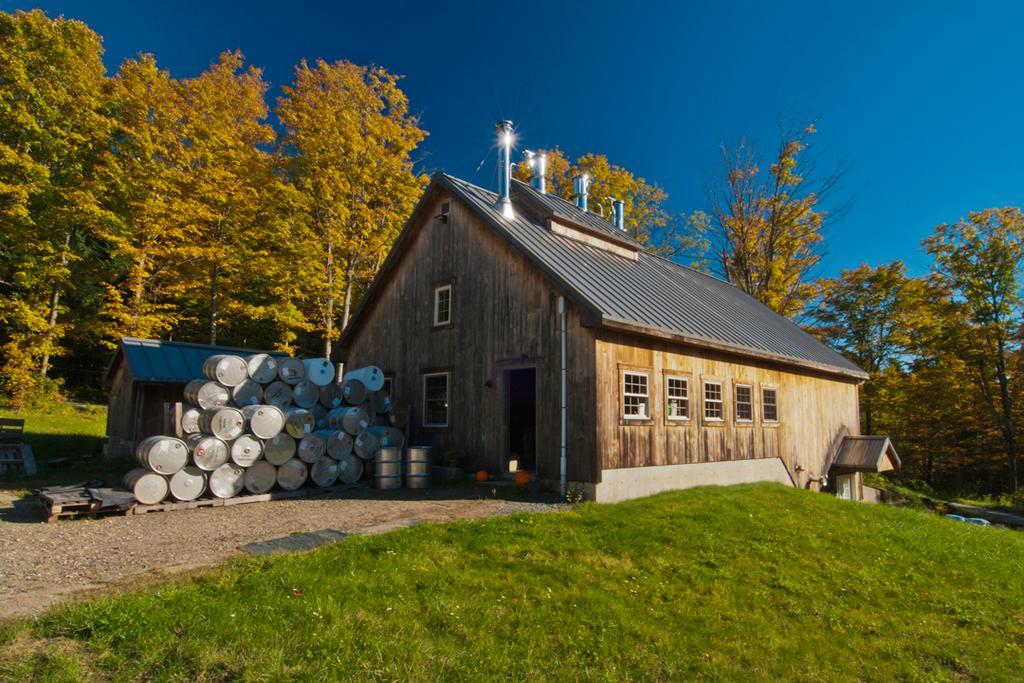How would you summarize this image in a sentence or two? In the picture I can see houses, drums, the grass, trees and some other objects on the ground. In the background I can see the sky. 